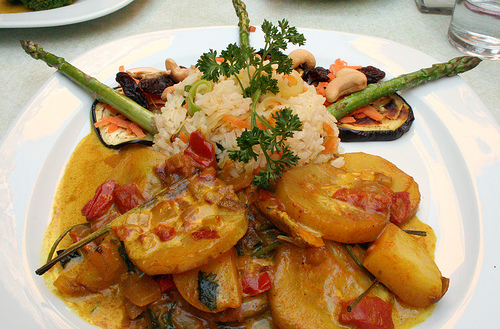<image>
Is the food on the plate? Yes. Looking at the image, I can see the food is positioned on top of the plate, with the plate providing support. Where is the rice in relation to the sauce? Is it next to the sauce? Yes. The rice is positioned adjacent to the sauce, located nearby in the same general area. 